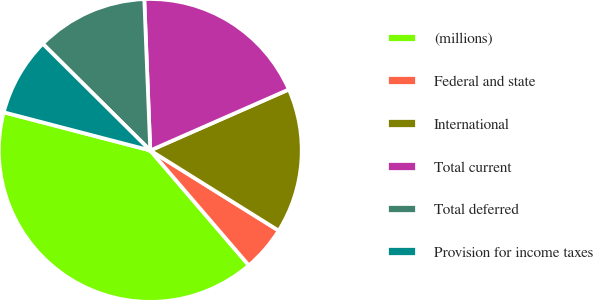<chart> <loc_0><loc_0><loc_500><loc_500><pie_chart><fcel>(millions)<fcel>Federal and state<fcel>International<fcel>Total current<fcel>Total deferred<fcel>Provision for income taxes<nl><fcel>40.33%<fcel>4.83%<fcel>15.48%<fcel>19.03%<fcel>11.93%<fcel>8.38%<nl></chart> 